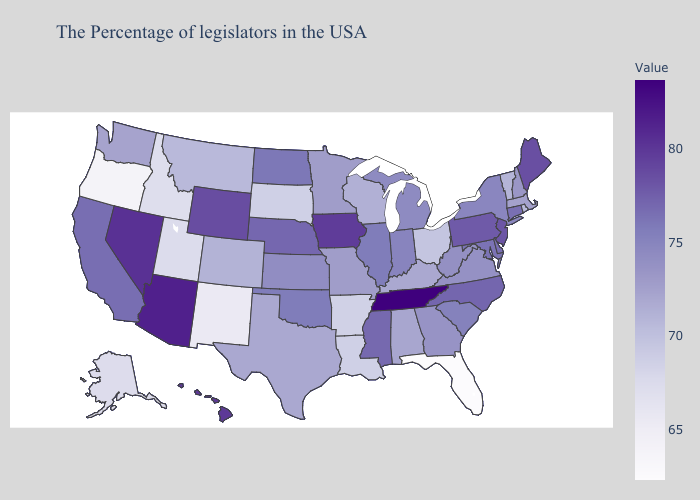Among the states that border Mississippi , does Louisiana have the highest value?
Quick response, please. No. Does the map have missing data?
Short answer required. No. Among the states that border Delaware , does Maryland have the lowest value?
Be succinct. Yes. Which states have the lowest value in the West?
Answer briefly. Oregon. Does Montana have the lowest value in the West?
Be succinct. No. Among the states that border Kentucky , which have the highest value?
Short answer required. Tennessee. Does Massachusetts have the lowest value in the Northeast?
Keep it brief. No. Does Nebraska have the lowest value in the MidWest?
Write a very short answer. No. 